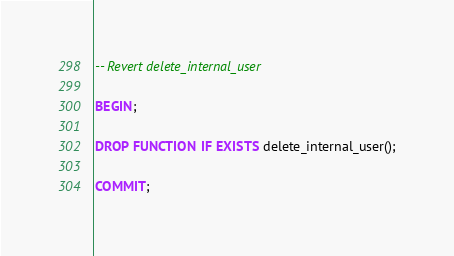<code> <loc_0><loc_0><loc_500><loc_500><_SQL_>-- Revert delete_internal_user

BEGIN;

DROP FUNCTION IF EXISTS delete_internal_user();

COMMIT;
</code> 